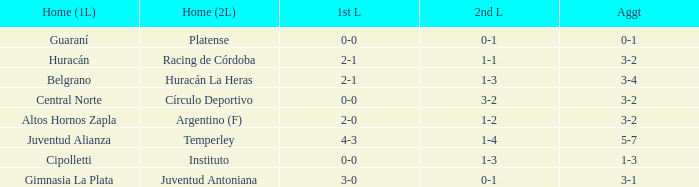What was the total score with a 1-2 outcome in the second leg? 3-2. 